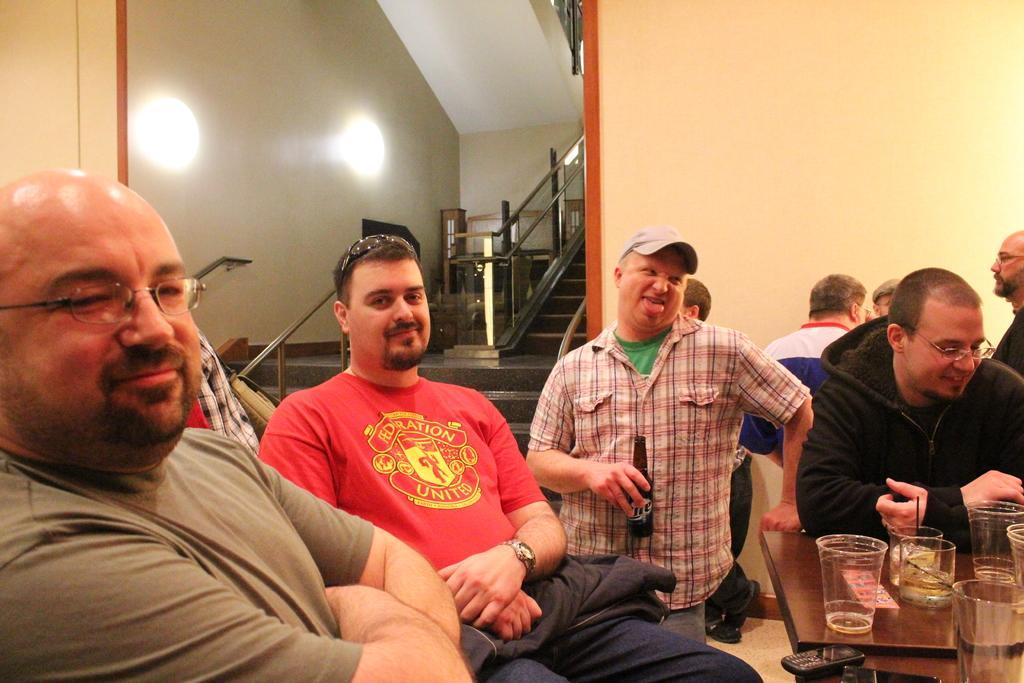How would you summarize this image in a sentence or two? In the image there are many men sitting in front of table with glasses on it, in the back there are steps beside the wall with lights on it, in the middle there is a man in cap and holding a beer bottle. 